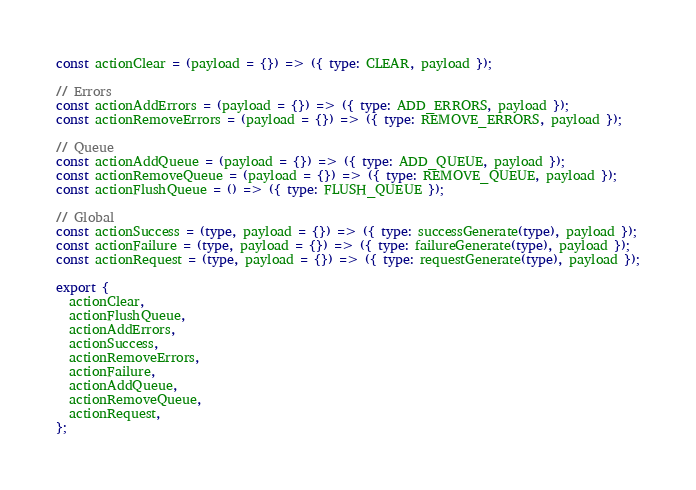Convert code to text. <code><loc_0><loc_0><loc_500><loc_500><_TypeScript_>const actionClear = (payload = {}) => ({ type: CLEAR, payload });

// Errors
const actionAddErrors = (payload = {}) => ({ type: ADD_ERRORS, payload });
const actionRemoveErrors = (payload = {}) => ({ type: REMOVE_ERRORS, payload });

// Queue
const actionAddQueue = (payload = {}) => ({ type: ADD_QUEUE, payload });
const actionRemoveQueue = (payload = {}) => ({ type: REMOVE_QUEUE, payload });
const actionFlushQueue = () => ({ type: FLUSH_QUEUE });

// Global
const actionSuccess = (type, payload = {}) => ({ type: successGenerate(type), payload });
const actionFailure = (type, payload = {}) => ({ type: failureGenerate(type), payload });
const actionRequest = (type, payload = {}) => ({ type: requestGenerate(type), payload });

export {
  actionClear,
  actionFlushQueue,
  actionAddErrors,
  actionSuccess,
  actionRemoveErrors,
  actionFailure,
  actionAddQueue,
  actionRemoveQueue,
  actionRequest,
};
</code> 